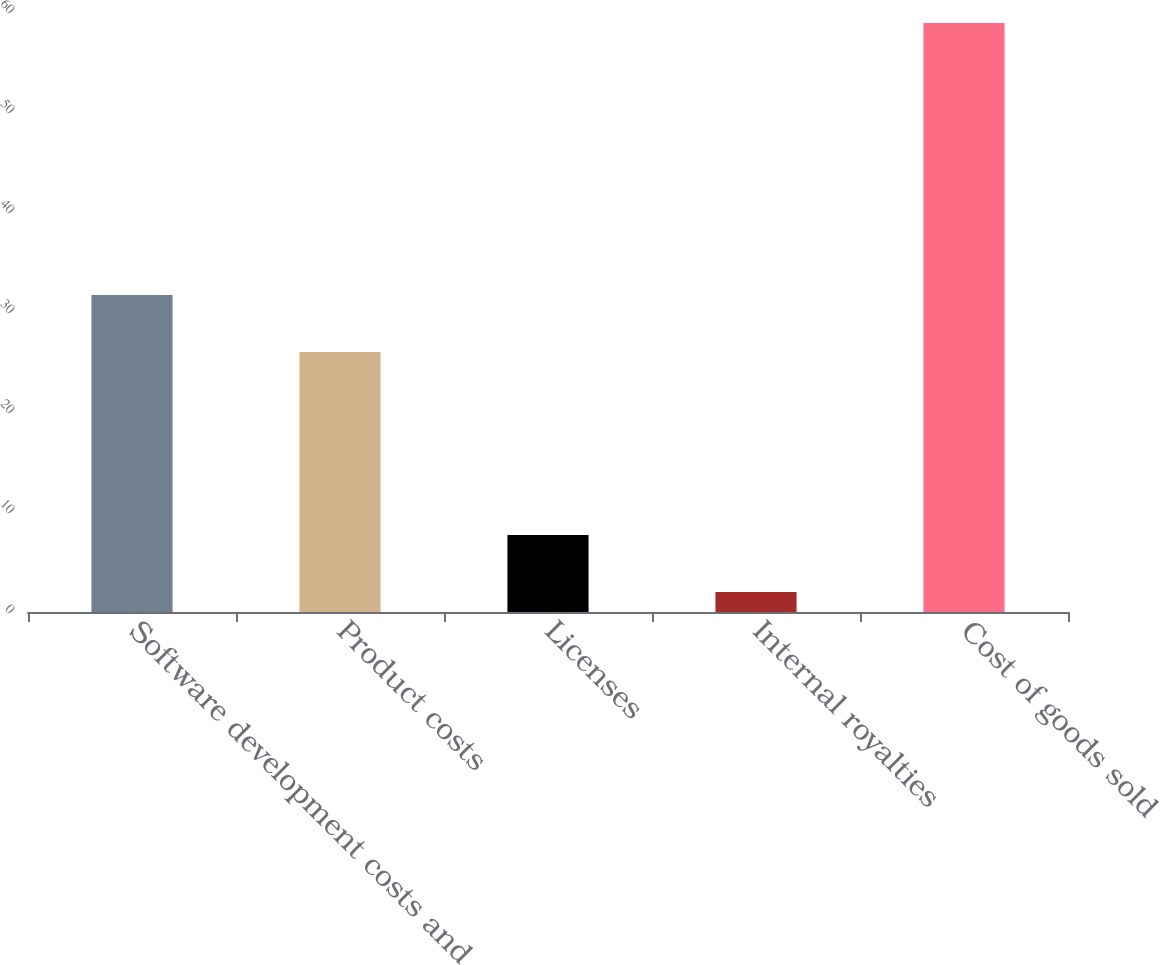Convert chart to OTSL. <chart><loc_0><loc_0><loc_500><loc_500><bar_chart><fcel>Software development costs and<fcel>Product costs<fcel>Licenses<fcel>Internal royalties<fcel>Cost of goods sold<nl><fcel>31.69<fcel>26<fcel>7.69<fcel>2<fcel>58.9<nl></chart> 